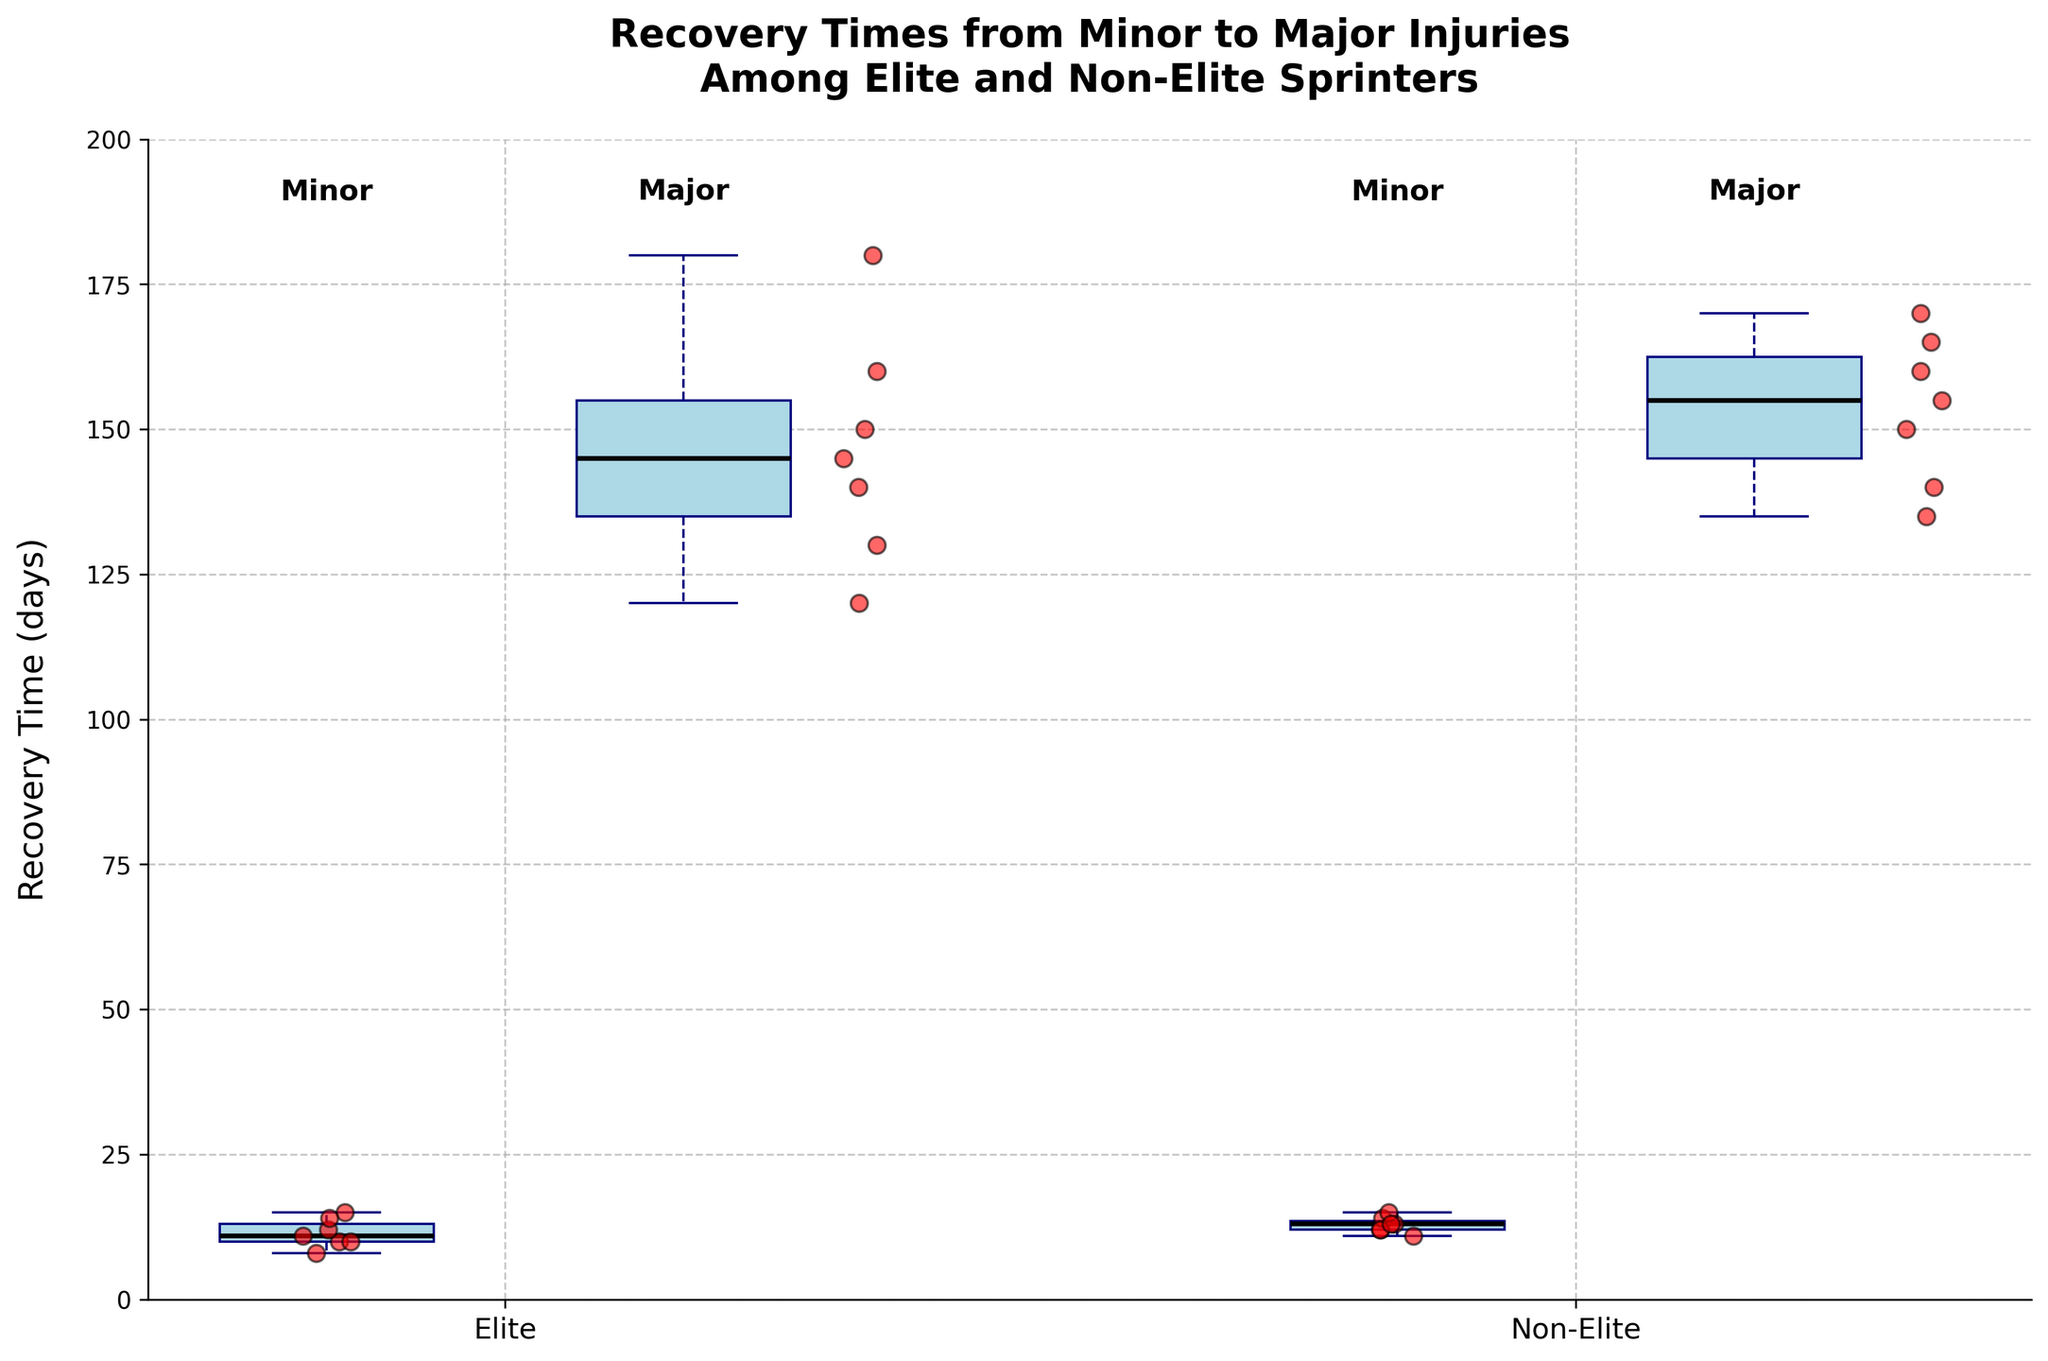What is the title of the plot? The title is centered at the top of the plot, detailing the main subject of the graph.
Answer: Recovery Times from Minor to Major Injuries Among Elite and Non-Elite Sprinters What does the y-axis represent? The y-axis is labeled and shows the measurement being plotted.
Answer: Recovery Time (days) Which category has the highest median recovery time for major injuries? To determine the highest median for major injuries, check the line inside the box at the major injury position for both Elite and Non-Elite groups.
Answer: Non-Elite What is the approximate median recovery time for minor injuries among Elite sprinters? Look at the line inside the box at position 1 corresponding to Elite Minor injuries.
Answer: 11 days How do the interquartile ranges (IQR) for minor injuries compare between Elite and Non-Elite sprinters? Compare the height of the boxes for Minor injuries between Elite (position 1) and Non-Elite (position 4) in the plot.
Answer: Elite IQR < Non-Elite IQR Are there any outliers noted for major injuries among Non-Elite sprinters? Check for individual points far from the central box at position 5.
Answer: No Which set of sprinters shows more variability in recovery time for major injuries, Elite or Non-Elite? Compare the length of the whiskers and the width of the boxes for major injuries between Elite (position 2) and Non-Elite (position 5).
Answer: Non-Elite What can be inferred about the overall recovery times of elite vs. non-elite sprinters from the plot? By comparing the spread and medians of the box plots for both injury types across the two groups, we infer recovery times trends.
Answer: Non-Elite sprinters generally have higher and more variable recovery times 